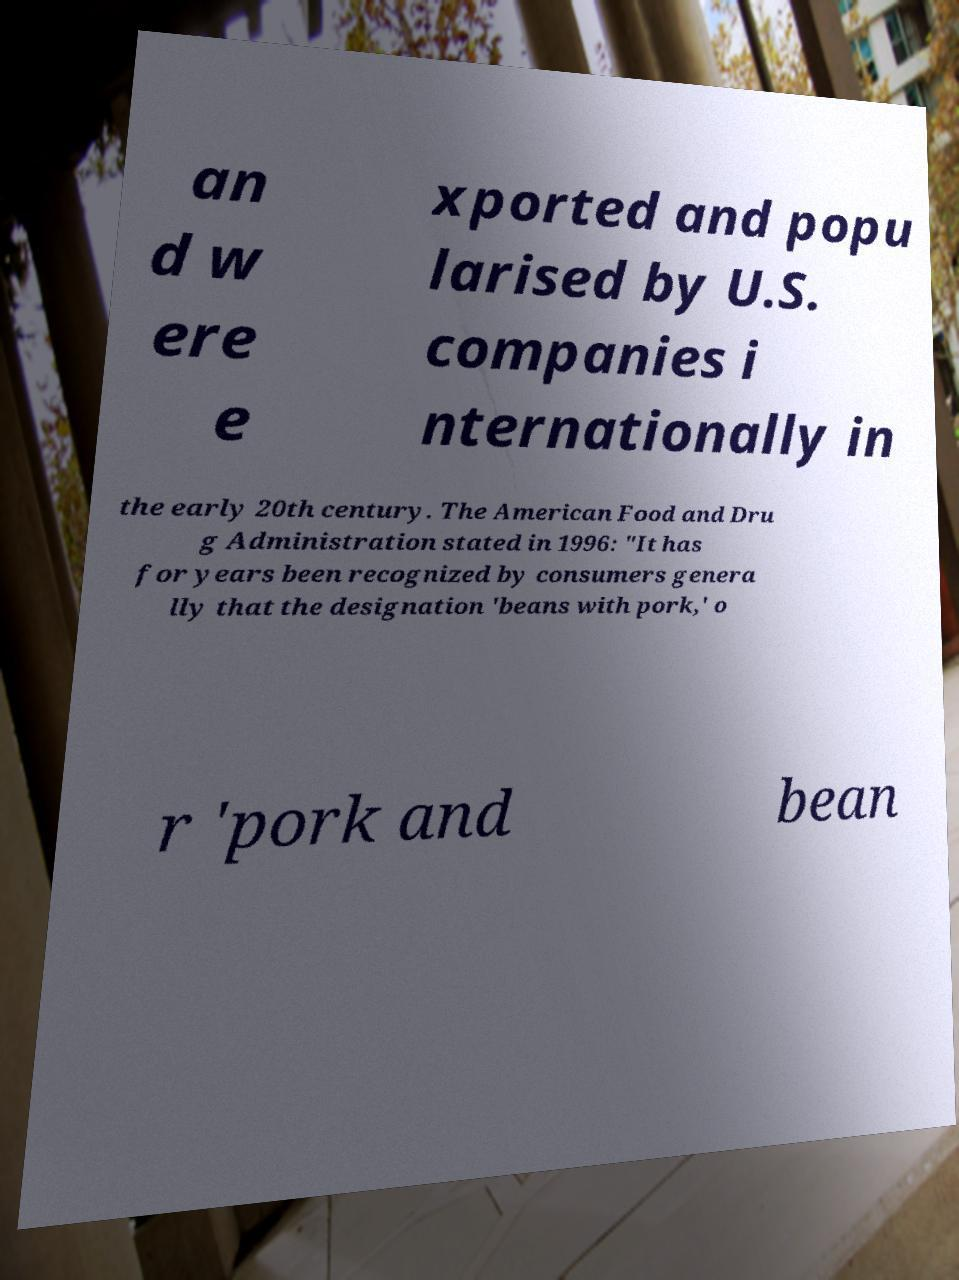What messages or text are displayed in this image? I need them in a readable, typed format. an d w ere e xported and popu larised by U.S. companies i nternationally in the early 20th century. The American Food and Dru g Administration stated in 1996: "It has for years been recognized by consumers genera lly that the designation 'beans with pork,' o r 'pork and bean 